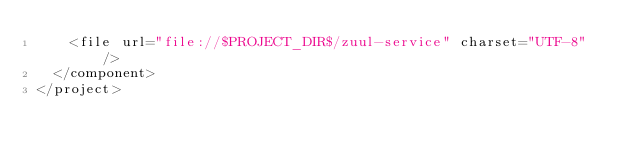<code> <loc_0><loc_0><loc_500><loc_500><_XML_>    <file url="file://$PROJECT_DIR$/zuul-service" charset="UTF-8" />
  </component>
</project></code> 